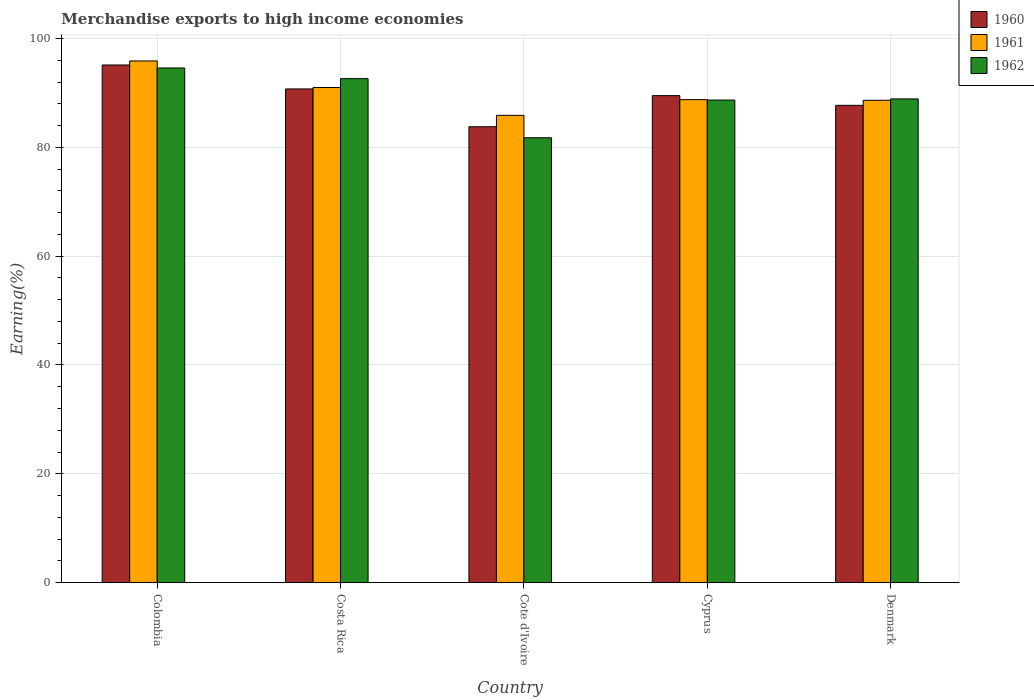How many different coloured bars are there?
Your answer should be very brief. 3. Are the number of bars per tick equal to the number of legend labels?
Offer a very short reply. Yes. Are the number of bars on each tick of the X-axis equal?
Offer a terse response. Yes. How many bars are there on the 2nd tick from the left?
Your response must be concise. 3. How many bars are there on the 2nd tick from the right?
Your answer should be very brief. 3. What is the label of the 3rd group of bars from the left?
Your answer should be compact. Cote d'Ivoire. In how many cases, is the number of bars for a given country not equal to the number of legend labels?
Your answer should be very brief. 0. What is the percentage of amount earned from merchandise exports in 1962 in Costa Rica?
Offer a very short reply. 92.64. Across all countries, what is the maximum percentage of amount earned from merchandise exports in 1962?
Provide a short and direct response. 94.6. Across all countries, what is the minimum percentage of amount earned from merchandise exports in 1960?
Offer a terse response. 83.8. In which country was the percentage of amount earned from merchandise exports in 1962 maximum?
Ensure brevity in your answer.  Colombia. In which country was the percentage of amount earned from merchandise exports in 1960 minimum?
Keep it short and to the point. Cote d'Ivoire. What is the total percentage of amount earned from merchandise exports in 1962 in the graph?
Provide a short and direct response. 446.61. What is the difference between the percentage of amount earned from merchandise exports in 1961 in Colombia and that in Costa Rica?
Your answer should be very brief. 4.87. What is the difference between the percentage of amount earned from merchandise exports in 1960 in Cyprus and the percentage of amount earned from merchandise exports in 1961 in Colombia?
Make the answer very short. -6.37. What is the average percentage of amount earned from merchandise exports in 1962 per country?
Your answer should be very brief. 89.32. What is the difference between the percentage of amount earned from merchandise exports of/in 1960 and percentage of amount earned from merchandise exports of/in 1961 in Costa Rica?
Provide a short and direct response. -0.27. What is the ratio of the percentage of amount earned from merchandise exports in 1962 in Costa Rica to that in Cyprus?
Ensure brevity in your answer.  1.04. Is the difference between the percentage of amount earned from merchandise exports in 1960 in Cyprus and Denmark greater than the difference between the percentage of amount earned from merchandise exports in 1961 in Cyprus and Denmark?
Provide a short and direct response. Yes. What is the difference between the highest and the second highest percentage of amount earned from merchandise exports in 1960?
Keep it short and to the point. -1.23. What is the difference between the highest and the lowest percentage of amount earned from merchandise exports in 1960?
Provide a succinct answer. 11.35. What does the 3rd bar from the left in Cote d'Ivoire represents?
Ensure brevity in your answer.  1962. How many bars are there?
Your answer should be very brief. 15. Are all the bars in the graph horizontal?
Provide a short and direct response. No. How many countries are there in the graph?
Make the answer very short. 5. What is the difference between two consecutive major ticks on the Y-axis?
Keep it short and to the point. 20. Does the graph contain any zero values?
Make the answer very short. No. Does the graph contain grids?
Offer a terse response. Yes. How are the legend labels stacked?
Keep it short and to the point. Vertical. What is the title of the graph?
Give a very brief answer. Merchandise exports to high income economies. Does "2013" appear as one of the legend labels in the graph?
Ensure brevity in your answer.  No. What is the label or title of the X-axis?
Your answer should be very brief. Country. What is the label or title of the Y-axis?
Make the answer very short. Earning(%). What is the Earning(%) in 1960 in Colombia?
Your answer should be very brief. 95.14. What is the Earning(%) of 1961 in Colombia?
Give a very brief answer. 95.89. What is the Earning(%) of 1962 in Colombia?
Give a very brief answer. 94.6. What is the Earning(%) of 1960 in Costa Rica?
Offer a terse response. 90.74. What is the Earning(%) of 1961 in Costa Rica?
Offer a terse response. 91.01. What is the Earning(%) of 1962 in Costa Rica?
Your answer should be compact. 92.64. What is the Earning(%) in 1960 in Cote d'Ivoire?
Ensure brevity in your answer.  83.8. What is the Earning(%) of 1961 in Cote d'Ivoire?
Offer a very short reply. 85.89. What is the Earning(%) in 1962 in Cote d'Ivoire?
Your response must be concise. 81.77. What is the Earning(%) in 1960 in Cyprus?
Your answer should be compact. 89.51. What is the Earning(%) in 1961 in Cyprus?
Keep it short and to the point. 88.78. What is the Earning(%) of 1962 in Cyprus?
Provide a short and direct response. 88.7. What is the Earning(%) in 1960 in Denmark?
Your answer should be compact. 87.73. What is the Earning(%) in 1961 in Denmark?
Provide a succinct answer. 88.66. What is the Earning(%) in 1962 in Denmark?
Offer a very short reply. 88.91. Across all countries, what is the maximum Earning(%) of 1960?
Your answer should be very brief. 95.14. Across all countries, what is the maximum Earning(%) in 1961?
Make the answer very short. 95.89. Across all countries, what is the maximum Earning(%) of 1962?
Your answer should be compact. 94.6. Across all countries, what is the minimum Earning(%) in 1960?
Give a very brief answer. 83.8. Across all countries, what is the minimum Earning(%) of 1961?
Offer a very short reply. 85.89. Across all countries, what is the minimum Earning(%) of 1962?
Ensure brevity in your answer.  81.77. What is the total Earning(%) of 1960 in the graph?
Ensure brevity in your answer.  446.92. What is the total Earning(%) of 1961 in the graph?
Give a very brief answer. 450.22. What is the total Earning(%) of 1962 in the graph?
Your answer should be very brief. 446.61. What is the difference between the Earning(%) of 1960 in Colombia and that in Costa Rica?
Your response must be concise. 4.4. What is the difference between the Earning(%) of 1961 in Colombia and that in Costa Rica?
Your answer should be compact. 4.87. What is the difference between the Earning(%) in 1962 in Colombia and that in Costa Rica?
Your answer should be very brief. 1.96. What is the difference between the Earning(%) in 1960 in Colombia and that in Cote d'Ivoire?
Offer a very short reply. 11.35. What is the difference between the Earning(%) in 1961 in Colombia and that in Cote d'Ivoire?
Offer a terse response. 10. What is the difference between the Earning(%) of 1962 in Colombia and that in Cote d'Ivoire?
Provide a short and direct response. 12.83. What is the difference between the Earning(%) of 1960 in Colombia and that in Cyprus?
Offer a very short reply. 5.63. What is the difference between the Earning(%) of 1961 in Colombia and that in Cyprus?
Provide a short and direct response. 7.11. What is the difference between the Earning(%) in 1962 in Colombia and that in Cyprus?
Offer a very short reply. 5.9. What is the difference between the Earning(%) of 1960 in Colombia and that in Denmark?
Offer a very short reply. 7.42. What is the difference between the Earning(%) of 1961 in Colombia and that in Denmark?
Provide a succinct answer. 7.23. What is the difference between the Earning(%) in 1962 in Colombia and that in Denmark?
Your answer should be compact. 5.69. What is the difference between the Earning(%) in 1960 in Costa Rica and that in Cote d'Ivoire?
Your answer should be compact. 6.95. What is the difference between the Earning(%) in 1961 in Costa Rica and that in Cote d'Ivoire?
Your answer should be compact. 5.12. What is the difference between the Earning(%) in 1962 in Costa Rica and that in Cote d'Ivoire?
Your answer should be compact. 10.87. What is the difference between the Earning(%) in 1960 in Costa Rica and that in Cyprus?
Offer a terse response. 1.23. What is the difference between the Earning(%) of 1961 in Costa Rica and that in Cyprus?
Keep it short and to the point. 2.24. What is the difference between the Earning(%) of 1962 in Costa Rica and that in Cyprus?
Your answer should be very brief. 3.94. What is the difference between the Earning(%) in 1960 in Costa Rica and that in Denmark?
Your answer should be very brief. 3.01. What is the difference between the Earning(%) in 1961 in Costa Rica and that in Denmark?
Keep it short and to the point. 2.36. What is the difference between the Earning(%) in 1962 in Costa Rica and that in Denmark?
Your answer should be compact. 3.73. What is the difference between the Earning(%) of 1960 in Cote d'Ivoire and that in Cyprus?
Your answer should be very brief. -5.72. What is the difference between the Earning(%) in 1961 in Cote d'Ivoire and that in Cyprus?
Make the answer very short. -2.88. What is the difference between the Earning(%) in 1962 in Cote d'Ivoire and that in Cyprus?
Provide a succinct answer. -6.92. What is the difference between the Earning(%) in 1960 in Cote d'Ivoire and that in Denmark?
Offer a terse response. -3.93. What is the difference between the Earning(%) of 1961 in Cote d'Ivoire and that in Denmark?
Your answer should be compact. -2.76. What is the difference between the Earning(%) of 1962 in Cote d'Ivoire and that in Denmark?
Keep it short and to the point. -7.14. What is the difference between the Earning(%) in 1960 in Cyprus and that in Denmark?
Your answer should be very brief. 1.78. What is the difference between the Earning(%) in 1961 in Cyprus and that in Denmark?
Ensure brevity in your answer.  0.12. What is the difference between the Earning(%) of 1962 in Cyprus and that in Denmark?
Offer a very short reply. -0.21. What is the difference between the Earning(%) in 1960 in Colombia and the Earning(%) in 1961 in Costa Rica?
Provide a succinct answer. 4.13. What is the difference between the Earning(%) of 1960 in Colombia and the Earning(%) of 1962 in Costa Rica?
Ensure brevity in your answer.  2.51. What is the difference between the Earning(%) in 1961 in Colombia and the Earning(%) in 1962 in Costa Rica?
Offer a terse response. 3.25. What is the difference between the Earning(%) of 1960 in Colombia and the Earning(%) of 1961 in Cote d'Ivoire?
Make the answer very short. 9.25. What is the difference between the Earning(%) in 1960 in Colombia and the Earning(%) in 1962 in Cote d'Ivoire?
Provide a short and direct response. 13.37. What is the difference between the Earning(%) of 1961 in Colombia and the Earning(%) of 1962 in Cote d'Ivoire?
Ensure brevity in your answer.  14.11. What is the difference between the Earning(%) in 1960 in Colombia and the Earning(%) in 1961 in Cyprus?
Offer a very short reply. 6.37. What is the difference between the Earning(%) of 1960 in Colombia and the Earning(%) of 1962 in Cyprus?
Make the answer very short. 6.45. What is the difference between the Earning(%) in 1961 in Colombia and the Earning(%) in 1962 in Cyprus?
Your response must be concise. 7.19. What is the difference between the Earning(%) in 1960 in Colombia and the Earning(%) in 1961 in Denmark?
Ensure brevity in your answer.  6.49. What is the difference between the Earning(%) of 1960 in Colombia and the Earning(%) of 1962 in Denmark?
Offer a very short reply. 6.24. What is the difference between the Earning(%) in 1961 in Colombia and the Earning(%) in 1962 in Denmark?
Provide a short and direct response. 6.98. What is the difference between the Earning(%) of 1960 in Costa Rica and the Earning(%) of 1961 in Cote d'Ivoire?
Give a very brief answer. 4.85. What is the difference between the Earning(%) of 1960 in Costa Rica and the Earning(%) of 1962 in Cote d'Ivoire?
Your answer should be compact. 8.97. What is the difference between the Earning(%) in 1961 in Costa Rica and the Earning(%) in 1962 in Cote d'Ivoire?
Your answer should be very brief. 9.24. What is the difference between the Earning(%) of 1960 in Costa Rica and the Earning(%) of 1961 in Cyprus?
Your response must be concise. 1.97. What is the difference between the Earning(%) in 1960 in Costa Rica and the Earning(%) in 1962 in Cyprus?
Ensure brevity in your answer.  2.05. What is the difference between the Earning(%) of 1961 in Costa Rica and the Earning(%) of 1962 in Cyprus?
Offer a very short reply. 2.32. What is the difference between the Earning(%) in 1960 in Costa Rica and the Earning(%) in 1961 in Denmark?
Offer a very short reply. 2.09. What is the difference between the Earning(%) of 1960 in Costa Rica and the Earning(%) of 1962 in Denmark?
Your response must be concise. 1.83. What is the difference between the Earning(%) in 1961 in Costa Rica and the Earning(%) in 1962 in Denmark?
Offer a terse response. 2.1. What is the difference between the Earning(%) of 1960 in Cote d'Ivoire and the Earning(%) of 1961 in Cyprus?
Make the answer very short. -4.98. What is the difference between the Earning(%) in 1960 in Cote d'Ivoire and the Earning(%) in 1962 in Cyprus?
Give a very brief answer. -4.9. What is the difference between the Earning(%) of 1961 in Cote d'Ivoire and the Earning(%) of 1962 in Cyprus?
Your answer should be very brief. -2.8. What is the difference between the Earning(%) in 1960 in Cote d'Ivoire and the Earning(%) in 1961 in Denmark?
Your response must be concise. -4.86. What is the difference between the Earning(%) of 1960 in Cote d'Ivoire and the Earning(%) of 1962 in Denmark?
Offer a very short reply. -5.11. What is the difference between the Earning(%) of 1961 in Cote d'Ivoire and the Earning(%) of 1962 in Denmark?
Provide a short and direct response. -3.02. What is the difference between the Earning(%) in 1960 in Cyprus and the Earning(%) in 1961 in Denmark?
Your answer should be very brief. 0.86. What is the difference between the Earning(%) of 1960 in Cyprus and the Earning(%) of 1962 in Denmark?
Make the answer very short. 0.6. What is the difference between the Earning(%) of 1961 in Cyprus and the Earning(%) of 1962 in Denmark?
Provide a succinct answer. -0.13. What is the average Earning(%) in 1960 per country?
Your answer should be compact. 89.38. What is the average Earning(%) of 1961 per country?
Your response must be concise. 90.04. What is the average Earning(%) of 1962 per country?
Your response must be concise. 89.32. What is the difference between the Earning(%) of 1960 and Earning(%) of 1961 in Colombia?
Offer a terse response. -0.74. What is the difference between the Earning(%) in 1960 and Earning(%) in 1962 in Colombia?
Ensure brevity in your answer.  0.55. What is the difference between the Earning(%) of 1961 and Earning(%) of 1962 in Colombia?
Keep it short and to the point. 1.29. What is the difference between the Earning(%) in 1960 and Earning(%) in 1961 in Costa Rica?
Make the answer very short. -0.27. What is the difference between the Earning(%) of 1960 and Earning(%) of 1962 in Costa Rica?
Provide a succinct answer. -1.9. What is the difference between the Earning(%) in 1961 and Earning(%) in 1962 in Costa Rica?
Provide a short and direct response. -1.63. What is the difference between the Earning(%) of 1960 and Earning(%) of 1961 in Cote d'Ivoire?
Provide a succinct answer. -2.1. What is the difference between the Earning(%) in 1960 and Earning(%) in 1962 in Cote d'Ivoire?
Ensure brevity in your answer.  2.02. What is the difference between the Earning(%) of 1961 and Earning(%) of 1962 in Cote d'Ivoire?
Offer a very short reply. 4.12. What is the difference between the Earning(%) in 1960 and Earning(%) in 1961 in Cyprus?
Offer a terse response. 0.74. What is the difference between the Earning(%) in 1960 and Earning(%) in 1962 in Cyprus?
Give a very brief answer. 0.82. What is the difference between the Earning(%) of 1961 and Earning(%) of 1962 in Cyprus?
Provide a short and direct response. 0.08. What is the difference between the Earning(%) of 1960 and Earning(%) of 1961 in Denmark?
Give a very brief answer. -0.93. What is the difference between the Earning(%) of 1960 and Earning(%) of 1962 in Denmark?
Your response must be concise. -1.18. What is the difference between the Earning(%) in 1961 and Earning(%) in 1962 in Denmark?
Keep it short and to the point. -0.25. What is the ratio of the Earning(%) in 1960 in Colombia to that in Costa Rica?
Keep it short and to the point. 1.05. What is the ratio of the Earning(%) of 1961 in Colombia to that in Costa Rica?
Ensure brevity in your answer.  1.05. What is the ratio of the Earning(%) in 1962 in Colombia to that in Costa Rica?
Provide a short and direct response. 1.02. What is the ratio of the Earning(%) in 1960 in Colombia to that in Cote d'Ivoire?
Your response must be concise. 1.14. What is the ratio of the Earning(%) of 1961 in Colombia to that in Cote d'Ivoire?
Provide a succinct answer. 1.12. What is the ratio of the Earning(%) in 1962 in Colombia to that in Cote d'Ivoire?
Make the answer very short. 1.16. What is the ratio of the Earning(%) of 1960 in Colombia to that in Cyprus?
Your response must be concise. 1.06. What is the ratio of the Earning(%) of 1961 in Colombia to that in Cyprus?
Offer a terse response. 1.08. What is the ratio of the Earning(%) in 1962 in Colombia to that in Cyprus?
Make the answer very short. 1.07. What is the ratio of the Earning(%) of 1960 in Colombia to that in Denmark?
Ensure brevity in your answer.  1.08. What is the ratio of the Earning(%) in 1961 in Colombia to that in Denmark?
Your answer should be very brief. 1.08. What is the ratio of the Earning(%) in 1962 in Colombia to that in Denmark?
Your response must be concise. 1.06. What is the ratio of the Earning(%) in 1960 in Costa Rica to that in Cote d'Ivoire?
Offer a terse response. 1.08. What is the ratio of the Earning(%) of 1961 in Costa Rica to that in Cote d'Ivoire?
Your response must be concise. 1.06. What is the ratio of the Earning(%) in 1962 in Costa Rica to that in Cote d'Ivoire?
Provide a succinct answer. 1.13. What is the ratio of the Earning(%) of 1960 in Costa Rica to that in Cyprus?
Provide a short and direct response. 1.01. What is the ratio of the Earning(%) in 1961 in Costa Rica to that in Cyprus?
Keep it short and to the point. 1.03. What is the ratio of the Earning(%) in 1962 in Costa Rica to that in Cyprus?
Give a very brief answer. 1.04. What is the ratio of the Earning(%) in 1960 in Costa Rica to that in Denmark?
Give a very brief answer. 1.03. What is the ratio of the Earning(%) in 1961 in Costa Rica to that in Denmark?
Your response must be concise. 1.03. What is the ratio of the Earning(%) in 1962 in Costa Rica to that in Denmark?
Your response must be concise. 1.04. What is the ratio of the Earning(%) of 1960 in Cote d'Ivoire to that in Cyprus?
Your answer should be compact. 0.94. What is the ratio of the Earning(%) in 1961 in Cote d'Ivoire to that in Cyprus?
Provide a short and direct response. 0.97. What is the ratio of the Earning(%) in 1962 in Cote d'Ivoire to that in Cyprus?
Make the answer very short. 0.92. What is the ratio of the Earning(%) of 1960 in Cote d'Ivoire to that in Denmark?
Your answer should be compact. 0.96. What is the ratio of the Earning(%) in 1961 in Cote d'Ivoire to that in Denmark?
Provide a succinct answer. 0.97. What is the ratio of the Earning(%) of 1962 in Cote d'Ivoire to that in Denmark?
Provide a succinct answer. 0.92. What is the ratio of the Earning(%) of 1960 in Cyprus to that in Denmark?
Offer a very short reply. 1.02. What is the ratio of the Earning(%) of 1961 in Cyprus to that in Denmark?
Ensure brevity in your answer.  1. What is the ratio of the Earning(%) of 1962 in Cyprus to that in Denmark?
Keep it short and to the point. 1. What is the difference between the highest and the second highest Earning(%) in 1960?
Your answer should be very brief. 4.4. What is the difference between the highest and the second highest Earning(%) in 1961?
Give a very brief answer. 4.87. What is the difference between the highest and the second highest Earning(%) of 1962?
Give a very brief answer. 1.96. What is the difference between the highest and the lowest Earning(%) in 1960?
Your response must be concise. 11.35. What is the difference between the highest and the lowest Earning(%) in 1961?
Your response must be concise. 10. What is the difference between the highest and the lowest Earning(%) of 1962?
Your response must be concise. 12.83. 